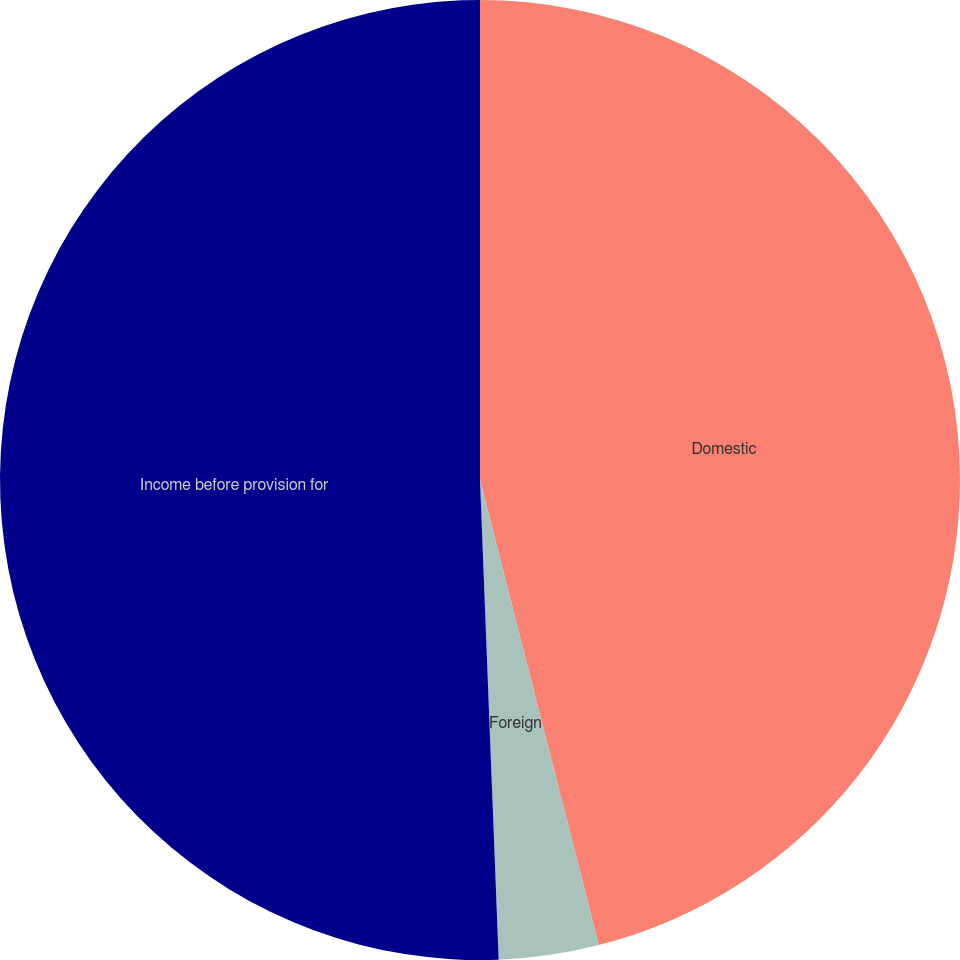<chart> <loc_0><loc_0><loc_500><loc_500><pie_chart><fcel>Domestic<fcel>Foreign<fcel>Income before provision for<nl><fcel>46.02%<fcel>3.36%<fcel>50.62%<nl></chart> 